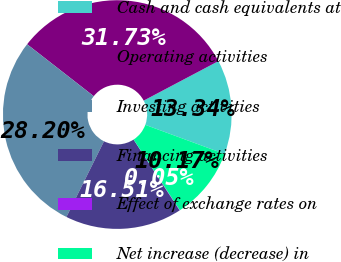Convert chart. <chart><loc_0><loc_0><loc_500><loc_500><pie_chart><fcel>Cash and cash equivalents at<fcel>Operating activities<fcel>Investing activities<fcel>Financing activities<fcel>Effect of exchange rates on<fcel>Net increase (decrease) in<nl><fcel>13.34%<fcel>31.73%<fcel>28.2%<fcel>16.51%<fcel>0.05%<fcel>10.17%<nl></chart> 